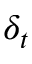Convert formula to latex. <formula><loc_0><loc_0><loc_500><loc_500>\delta _ { t }</formula> 